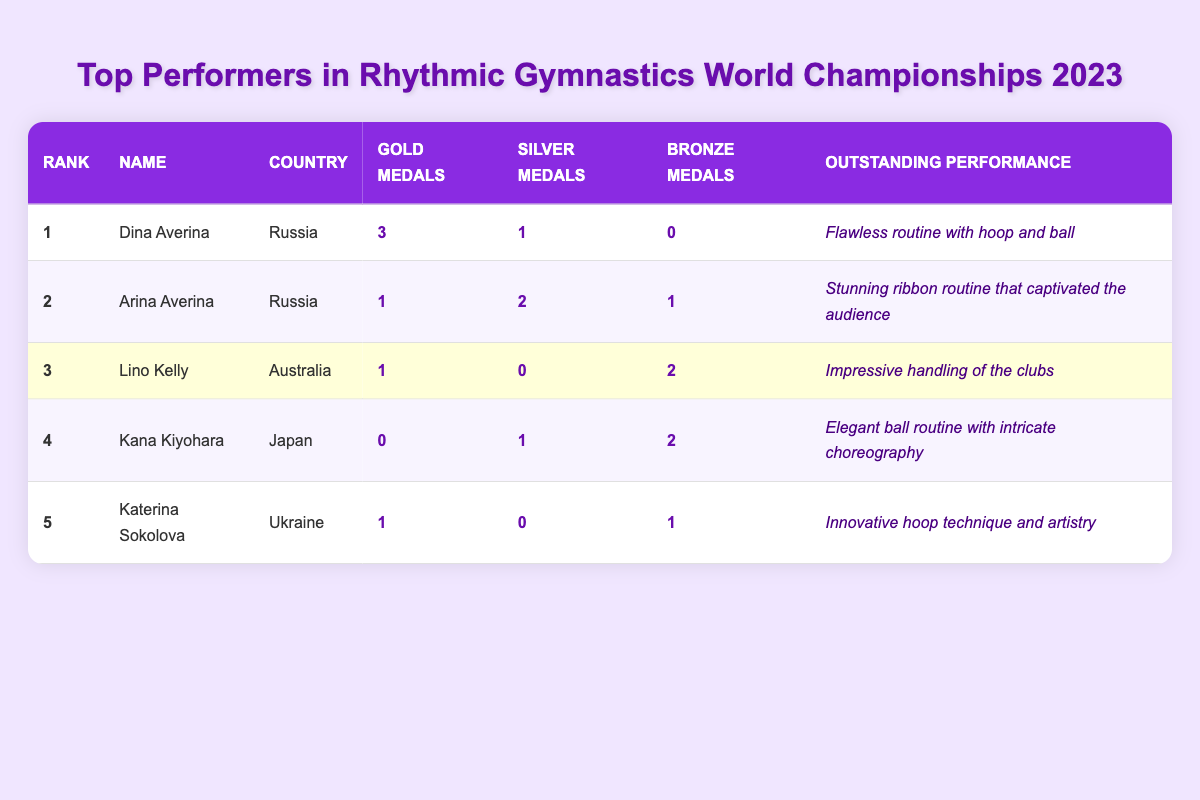What is the name of the top performer in the Rhythmic Gymnastics World Championships 2023? The table shows that the first rank is held by Dina Averina.
Answer: Dina Averina How many gold medals did Arina Averina win? The table lists Arina Averina with 1 gold medal in the gold medals column.
Answer: 1 Which country does Lino Kelly represent? According to the table, Lino Kelly is listed under the country column as representing Australia.
Answer: Australia What is the total number of medals won by Katerina Sokolova? Katerina Sokolova has 1 gold, 0 silver, and 1 bronze. Summing these gives a total of 1 + 0 + 1 = 2 medals.
Answer: 2 Did any athlete win more bronze medals than Lino Kelly? Lino Kelly has 2 bronze medals. The table shows Kana Kiyohara also has 2 bronze medals, which is equal, but no athlete has more than Lino Kelly.
Answer: No What is the average number of gold medals won by the top 5 performers? The sum of gold medals is 3 + 1 + 1 + 0 + 1 = 6. Dividing by 5 gives an average of 6 / 5 = 1.2.
Answer: 1.2 Which performer had the most outstanding performance? Looking through the outstanding performance descriptions, Dina Averina's routine is highlighted as flawless with hoop and ball, making her outstanding performance stand out the most.
Answer: Dina Averina How does the number of silver medals won by Arina Averina compare to that of Kana Kiyohara? Arina Averina has 2 silver medals while Kana Kiyohara has 1. The difference is 2 - 1 = 1, meaning Arina Averina has more silver medals.
Answer: Arina Averina has more by 1 Which gymnast received a bronze medal alongside having no gold medals? The table shows Kana Kiyohara has 0 gold medals and 2 bronze medals, fitting this criteria perfectly.
Answer: Kana Kiyohara What is the total count of silver medals across all top performers? Adding the silver medals gives (1 + 2 + 0 + 1 + 0) = 4 silver medals in total.
Answer: 4 